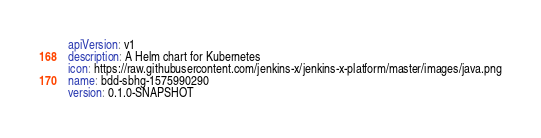Convert code to text. <code><loc_0><loc_0><loc_500><loc_500><_YAML_>apiVersion: v1
description: A Helm chart for Kubernetes
icon: https://raw.githubusercontent.com/jenkins-x/jenkins-x-platform/master/images/java.png
name: bdd-sbhg-1575990290
version: 0.1.0-SNAPSHOT
</code> 